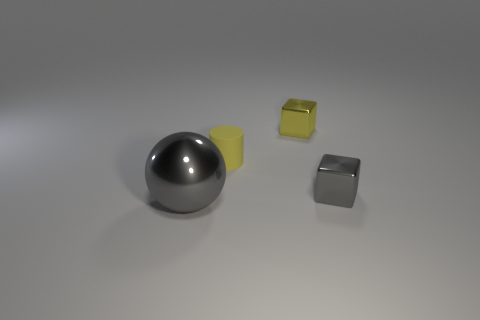Can you describe the materials of the objects shown? Certainly! In the image, there are three distinct objects that appear to be made from different materials. The sphere has a reflective, metallic finish, which suggests it might be made of metal or chrome. The yellow object has a more matte appearance, indicating it could be a plastic or rubber item. Lastly, the gray cube reflects light in a way that is indicative of either a metal or a polished stone finish. 